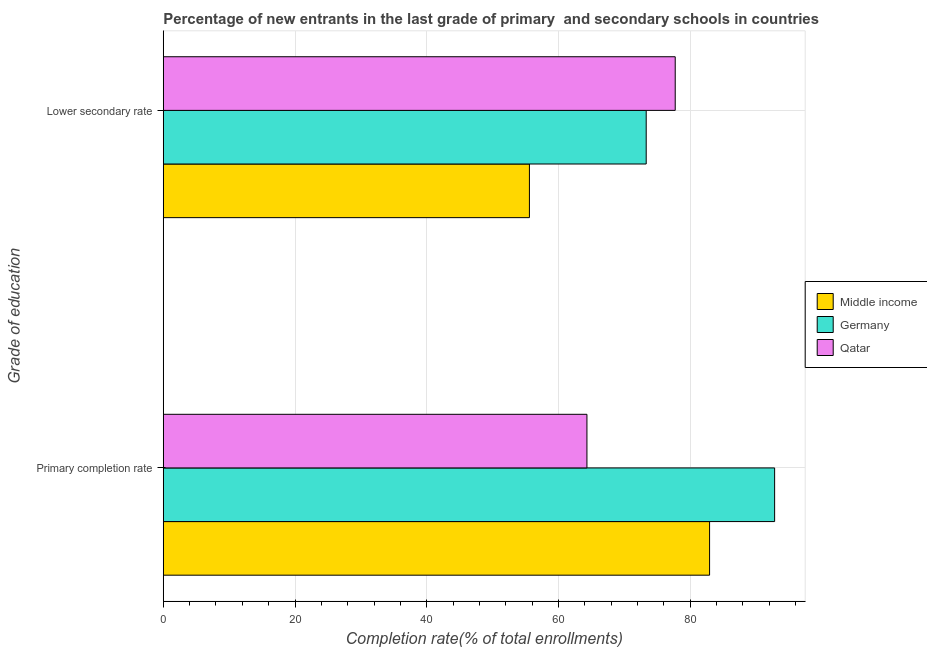How many groups of bars are there?
Keep it short and to the point. 2. Are the number of bars on each tick of the Y-axis equal?
Your answer should be very brief. Yes. How many bars are there on the 2nd tick from the bottom?
Make the answer very short. 3. What is the label of the 2nd group of bars from the top?
Ensure brevity in your answer.  Primary completion rate. What is the completion rate in secondary schools in Germany?
Your answer should be very brief. 73.32. Across all countries, what is the maximum completion rate in primary schools?
Keep it short and to the point. 92.82. Across all countries, what is the minimum completion rate in primary schools?
Make the answer very short. 64.33. In which country was the completion rate in primary schools maximum?
Provide a short and direct response. Germany. In which country was the completion rate in secondary schools minimum?
Give a very brief answer. Middle income. What is the total completion rate in secondary schools in the graph?
Your response must be concise. 206.65. What is the difference between the completion rate in primary schools in Germany and that in Middle income?
Give a very brief answer. 9.88. What is the difference between the completion rate in secondary schools in Middle income and the completion rate in primary schools in Qatar?
Offer a terse response. -8.73. What is the average completion rate in primary schools per country?
Ensure brevity in your answer.  80.03. What is the difference between the completion rate in primary schools and completion rate in secondary schools in Middle income?
Your answer should be very brief. 27.35. In how many countries, is the completion rate in secondary schools greater than 8 %?
Keep it short and to the point. 3. What is the ratio of the completion rate in primary schools in Qatar to that in Middle income?
Give a very brief answer. 0.78. Is the completion rate in secondary schools in Qatar less than that in Middle income?
Provide a short and direct response. No. In how many countries, is the completion rate in primary schools greater than the average completion rate in primary schools taken over all countries?
Make the answer very short. 2. What does the 2nd bar from the top in Lower secondary rate represents?
Ensure brevity in your answer.  Germany. How many bars are there?
Ensure brevity in your answer.  6. Are all the bars in the graph horizontal?
Offer a terse response. Yes. How many countries are there in the graph?
Provide a short and direct response. 3. Are the values on the major ticks of X-axis written in scientific E-notation?
Ensure brevity in your answer.  No. Does the graph contain any zero values?
Give a very brief answer. No. Does the graph contain grids?
Give a very brief answer. Yes. How are the legend labels stacked?
Give a very brief answer. Vertical. What is the title of the graph?
Your answer should be compact. Percentage of new entrants in the last grade of primary  and secondary schools in countries. Does "Bermuda" appear as one of the legend labels in the graph?
Ensure brevity in your answer.  No. What is the label or title of the X-axis?
Your response must be concise. Completion rate(% of total enrollments). What is the label or title of the Y-axis?
Ensure brevity in your answer.  Grade of education. What is the Completion rate(% of total enrollments) in Middle income in Primary completion rate?
Offer a very short reply. 82.95. What is the Completion rate(% of total enrollments) of Germany in Primary completion rate?
Offer a terse response. 92.82. What is the Completion rate(% of total enrollments) in Qatar in Primary completion rate?
Offer a very short reply. 64.33. What is the Completion rate(% of total enrollments) of Middle income in Lower secondary rate?
Ensure brevity in your answer.  55.59. What is the Completion rate(% of total enrollments) of Germany in Lower secondary rate?
Ensure brevity in your answer.  73.32. What is the Completion rate(% of total enrollments) in Qatar in Lower secondary rate?
Provide a succinct answer. 77.73. Across all Grade of education, what is the maximum Completion rate(% of total enrollments) of Middle income?
Keep it short and to the point. 82.95. Across all Grade of education, what is the maximum Completion rate(% of total enrollments) of Germany?
Give a very brief answer. 92.82. Across all Grade of education, what is the maximum Completion rate(% of total enrollments) of Qatar?
Your answer should be very brief. 77.73. Across all Grade of education, what is the minimum Completion rate(% of total enrollments) of Middle income?
Provide a short and direct response. 55.59. Across all Grade of education, what is the minimum Completion rate(% of total enrollments) of Germany?
Give a very brief answer. 73.32. Across all Grade of education, what is the minimum Completion rate(% of total enrollments) of Qatar?
Your answer should be compact. 64.33. What is the total Completion rate(% of total enrollments) of Middle income in the graph?
Provide a short and direct response. 138.54. What is the total Completion rate(% of total enrollments) in Germany in the graph?
Offer a terse response. 166.15. What is the total Completion rate(% of total enrollments) in Qatar in the graph?
Your answer should be very brief. 142.06. What is the difference between the Completion rate(% of total enrollments) of Middle income in Primary completion rate and that in Lower secondary rate?
Give a very brief answer. 27.35. What is the difference between the Completion rate(% of total enrollments) of Germany in Primary completion rate and that in Lower secondary rate?
Your answer should be very brief. 19.5. What is the difference between the Completion rate(% of total enrollments) in Qatar in Primary completion rate and that in Lower secondary rate?
Provide a short and direct response. -13.4. What is the difference between the Completion rate(% of total enrollments) in Middle income in Primary completion rate and the Completion rate(% of total enrollments) in Germany in Lower secondary rate?
Make the answer very short. 9.62. What is the difference between the Completion rate(% of total enrollments) of Middle income in Primary completion rate and the Completion rate(% of total enrollments) of Qatar in Lower secondary rate?
Make the answer very short. 5.22. What is the difference between the Completion rate(% of total enrollments) of Germany in Primary completion rate and the Completion rate(% of total enrollments) of Qatar in Lower secondary rate?
Provide a short and direct response. 15.09. What is the average Completion rate(% of total enrollments) in Middle income per Grade of education?
Give a very brief answer. 69.27. What is the average Completion rate(% of total enrollments) in Germany per Grade of education?
Your answer should be very brief. 83.07. What is the average Completion rate(% of total enrollments) in Qatar per Grade of education?
Make the answer very short. 71.03. What is the difference between the Completion rate(% of total enrollments) in Middle income and Completion rate(% of total enrollments) in Germany in Primary completion rate?
Make the answer very short. -9.88. What is the difference between the Completion rate(% of total enrollments) of Middle income and Completion rate(% of total enrollments) of Qatar in Primary completion rate?
Your response must be concise. 18.62. What is the difference between the Completion rate(% of total enrollments) in Germany and Completion rate(% of total enrollments) in Qatar in Primary completion rate?
Offer a terse response. 28.5. What is the difference between the Completion rate(% of total enrollments) in Middle income and Completion rate(% of total enrollments) in Germany in Lower secondary rate?
Your response must be concise. -17.73. What is the difference between the Completion rate(% of total enrollments) in Middle income and Completion rate(% of total enrollments) in Qatar in Lower secondary rate?
Your answer should be compact. -22.14. What is the difference between the Completion rate(% of total enrollments) of Germany and Completion rate(% of total enrollments) of Qatar in Lower secondary rate?
Provide a short and direct response. -4.41. What is the ratio of the Completion rate(% of total enrollments) of Middle income in Primary completion rate to that in Lower secondary rate?
Offer a terse response. 1.49. What is the ratio of the Completion rate(% of total enrollments) of Germany in Primary completion rate to that in Lower secondary rate?
Your response must be concise. 1.27. What is the ratio of the Completion rate(% of total enrollments) in Qatar in Primary completion rate to that in Lower secondary rate?
Give a very brief answer. 0.83. What is the difference between the highest and the second highest Completion rate(% of total enrollments) of Middle income?
Your response must be concise. 27.35. What is the difference between the highest and the second highest Completion rate(% of total enrollments) of Germany?
Your answer should be very brief. 19.5. What is the difference between the highest and the second highest Completion rate(% of total enrollments) of Qatar?
Make the answer very short. 13.4. What is the difference between the highest and the lowest Completion rate(% of total enrollments) of Middle income?
Your response must be concise. 27.35. What is the difference between the highest and the lowest Completion rate(% of total enrollments) in Germany?
Your answer should be compact. 19.5. What is the difference between the highest and the lowest Completion rate(% of total enrollments) of Qatar?
Your response must be concise. 13.4. 